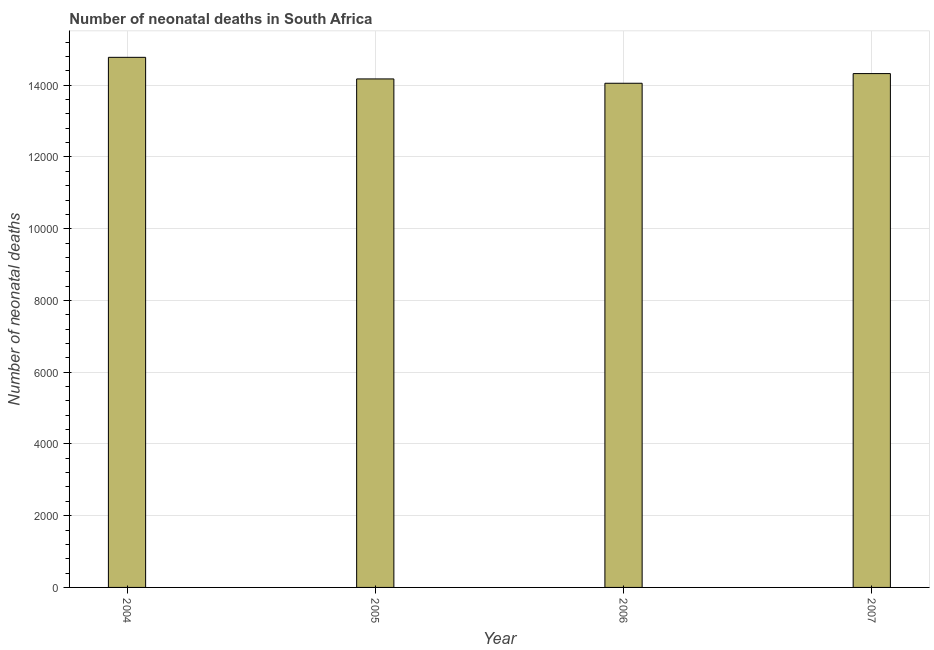Does the graph contain any zero values?
Provide a succinct answer. No. What is the title of the graph?
Ensure brevity in your answer.  Number of neonatal deaths in South Africa. What is the label or title of the Y-axis?
Provide a succinct answer. Number of neonatal deaths. What is the number of neonatal deaths in 2004?
Ensure brevity in your answer.  1.48e+04. Across all years, what is the maximum number of neonatal deaths?
Offer a very short reply. 1.48e+04. Across all years, what is the minimum number of neonatal deaths?
Your response must be concise. 1.41e+04. What is the sum of the number of neonatal deaths?
Your answer should be very brief. 5.73e+04. What is the difference between the number of neonatal deaths in 2006 and 2007?
Your response must be concise. -270. What is the average number of neonatal deaths per year?
Keep it short and to the point. 1.43e+04. What is the median number of neonatal deaths?
Your answer should be very brief. 1.43e+04. In how many years, is the number of neonatal deaths greater than 10400 ?
Your answer should be very brief. 4. Is the difference between the number of neonatal deaths in 2004 and 2005 greater than the difference between any two years?
Your response must be concise. No. What is the difference between the highest and the second highest number of neonatal deaths?
Offer a terse response. 453. Is the sum of the number of neonatal deaths in 2004 and 2007 greater than the maximum number of neonatal deaths across all years?
Provide a succinct answer. Yes. What is the difference between the highest and the lowest number of neonatal deaths?
Offer a terse response. 723. How many bars are there?
Provide a succinct answer. 4. Are all the bars in the graph horizontal?
Give a very brief answer. No. How many years are there in the graph?
Your answer should be very brief. 4. What is the difference between two consecutive major ticks on the Y-axis?
Give a very brief answer. 2000. Are the values on the major ticks of Y-axis written in scientific E-notation?
Offer a terse response. No. What is the Number of neonatal deaths of 2004?
Provide a short and direct response. 1.48e+04. What is the Number of neonatal deaths of 2005?
Your answer should be compact. 1.42e+04. What is the Number of neonatal deaths of 2006?
Give a very brief answer. 1.41e+04. What is the Number of neonatal deaths of 2007?
Your answer should be compact. 1.43e+04. What is the difference between the Number of neonatal deaths in 2004 and 2005?
Make the answer very short. 602. What is the difference between the Number of neonatal deaths in 2004 and 2006?
Make the answer very short. 723. What is the difference between the Number of neonatal deaths in 2004 and 2007?
Your response must be concise. 453. What is the difference between the Number of neonatal deaths in 2005 and 2006?
Offer a very short reply. 121. What is the difference between the Number of neonatal deaths in 2005 and 2007?
Your answer should be very brief. -149. What is the difference between the Number of neonatal deaths in 2006 and 2007?
Your answer should be very brief. -270. What is the ratio of the Number of neonatal deaths in 2004 to that in 2005?
Provide a short and direct response. 1.04. What is the ratio of the Number of neonatal deaths in 2004 to that in 2006?
Your answer should be compact. 1.05. What is the ratio of the Number of neonatal deaths in 2004 to that in 2007?
Offer a very short reply. 1.03. What is the ratio of the Number of neonatal deaths in 2005 to that in 2007?
Provide a succinct answer. 0.99. What is the ratio of the Number of neonatal deaths in 2006 to that in 2007?
Ensure brevity in your answer.  0.98. 